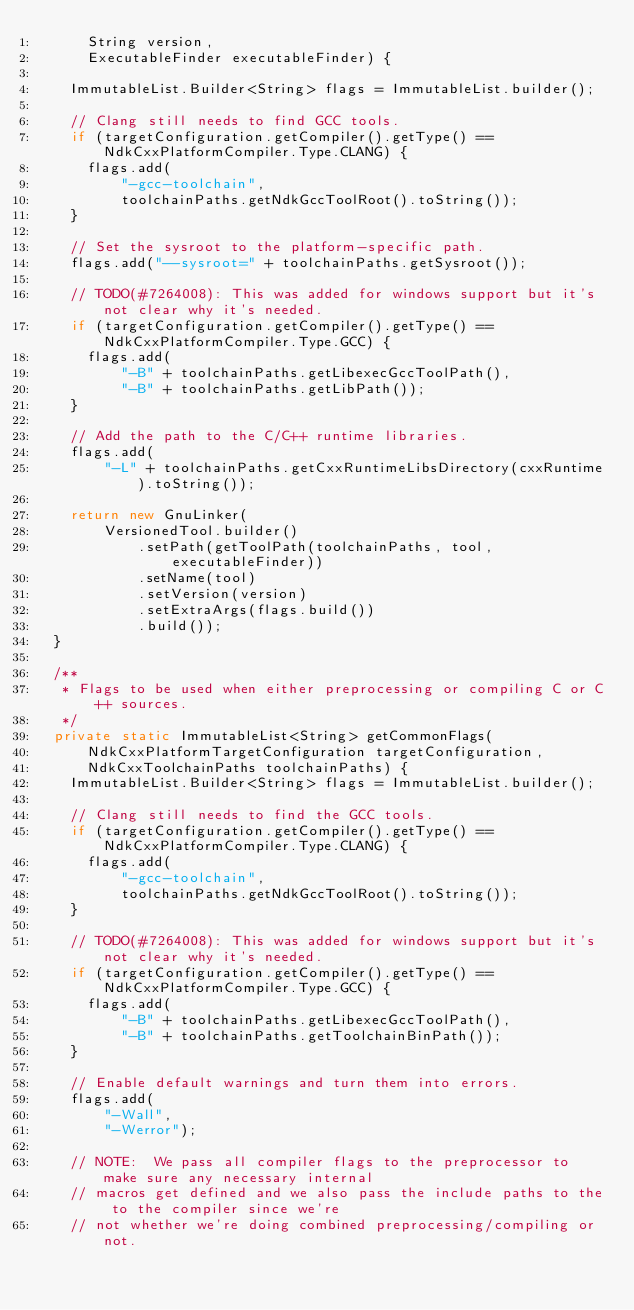Convert code to text. <code><loc_0><loc_0><loc_500><loc_500><_Java_>      String version,
      ExecutableFinder executableFinder) {

    ImmutableList.Builder<String> flags = ImmutableList.builder();

    // Clang still needs to find GCC tools.
    if (targetConfiguration.getCompiler().getType() == NdkCxxPlatformCompiler.Type.CLANG) {
      flags.add(
          "-gcc-toolchain",
          toolchainPaths.getNdkGccToolRoot().toString());
    }

    // Set the sysroot to the platform-specific path.
    flags.add("--sysroot=" + toolchainPaths.getSysroot());

    // TODO(#7264008): This was added for windows support but it's not clear why it's needed.
    if (targetConfiguration.getCompiler().getType() == NdkCxxPlatformCompiler.Type.GCC) {
      flags.add(
          "-B" + toolchainPaths.getLibexecGccToolPath(),
          "-B" + toolchainPaths.getLibPath());
    }

    // Add the path to the C/C++ runtime libraries.
    flags.add(
        "-L" + toolchainPaths.getCxxRuntimeLibsDirectory(cxxRuntime).toString());

    return new GnuLinker(
        VersionedTool.builder()
            .setPath(getToolPath(toolchainPaths, tool, executableFinder))
            .setName(tool)
            .setVersion(version)
            .setExtraArgs(flags.build())
            .build());
  }

  /**
   * Flags to be used when either preprocessing or compiling C or C++ sources.
   */
  private static ImmutableList<String> getCommonFlags(
      NdkCxxPlatformTargetConfiguration targetConfiguration,
      NdkCxxToolchainPaths toolchainPaths) {
    ImmutableList.Builder<String> flags = ImmutableList.builder();

    // Clang still needs to find the GCC tools.
    if (targetConfiguration.getCompiler().getType() == NdkCxxPlatformCompiler.Type.CLANG) {
      flags.add(
          "-gcc-toolchain",
          toolchainPaths.getNdkGccToolRoot().toString());
    }

    // TODO(#7264008): This was added for windows support but it's not clear why it's needed.
    if (targetConfiguration.getCompiler().getType() == NdkCxxPlatformCompiler.Type.GCC) {
      flags.add(
          "-B" + toolchainPaths.getLibexecGccToolPath(),
          "-B" + toolchainPaths.getToolchainBinPath());
    }

    // Enable default warnings and turn them into errors.
    flags.add(
        "-Wall",
        "-Werror");

    // NOTE:  We pass all compiler flags to the preprocessor to make sure any necessary internal
    // macros get defined and we also pass the include paths to the to the compiler since we're
    // not whether we're doing combined preprocessing/compiling or not.</code> 